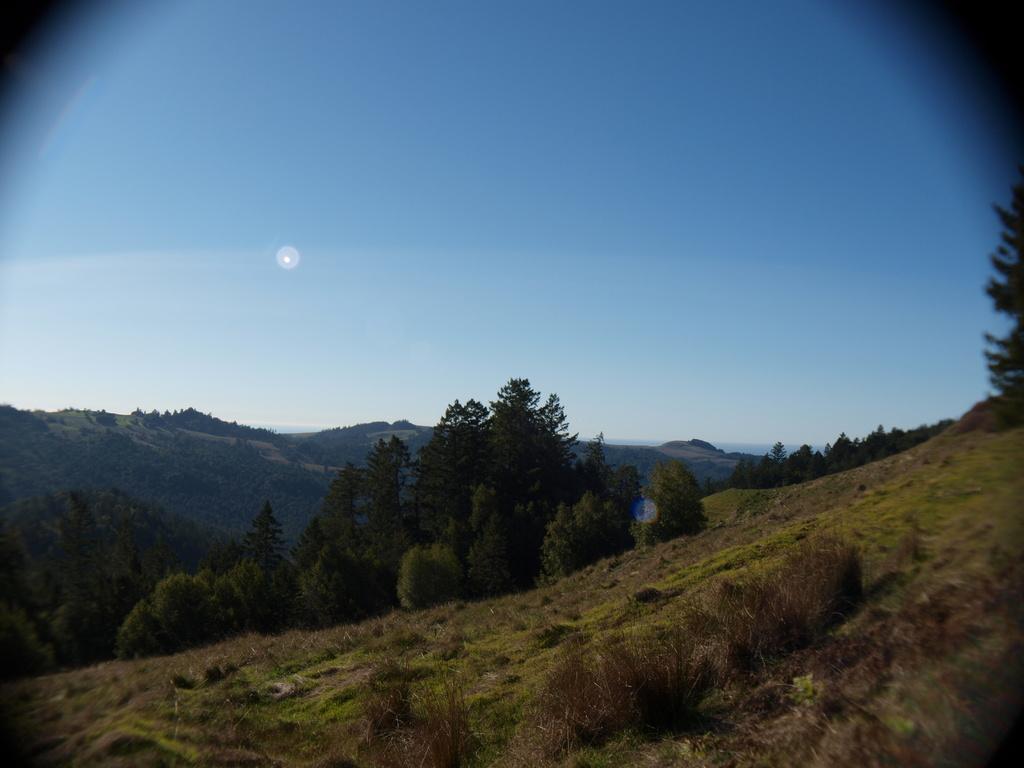Can you describe this image briefly? In this image, we can see some trees and plants. There are hills at the bottom of the image. There is a sky at the top of the image. 